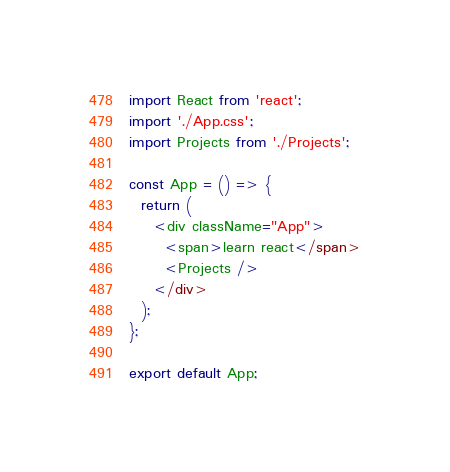<code> <loc_0><loc_0><loc_500><loc_500><_JavaScript_>import React from 'react';
import './App.css';
import Projects from './Projects';

const App = () => {
  return (
    <div className="App">
      <span>learn react</span>
      <Projects />
    </div>
  );
};

export default App;
</code> 